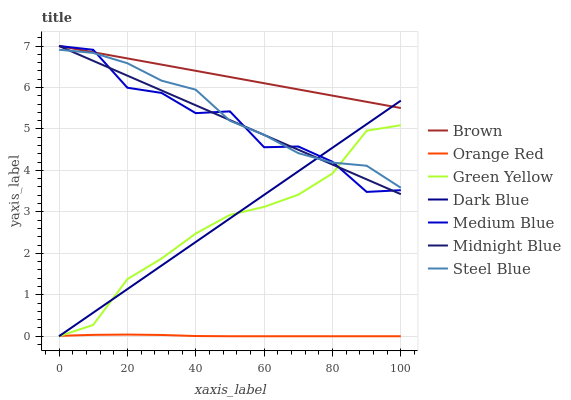Does Midnight Blue have the minimum area under the curve?
Answer yes or no. No. Does Midnight Blue have the maximum area under the curve?
Answer yes or no. No. Is Midnight Blue the smoothest?
Answer yes or no. No. Is Midnight Blue the roughest?
Answer yes or no. No. Does Midnight Blue have the lowest value?
Answer yes or no. No. Does Steel Blue have the highest value?
Answer yes or no. No. Is Orange Red less than Medium Blue?
Answer yes or no. Yes. Is Steel Blue greater than Orange Red?
Answer yes or no. Yes. Does Orange Red intersect Medium Blue?
Answer yes or no. No. 